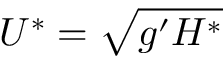<formula> <loc_0><loc_0><loc_500><loc_500>U ^ { * } = \sqrt { g ^ { \prime } H ^ { * } }</formula> 